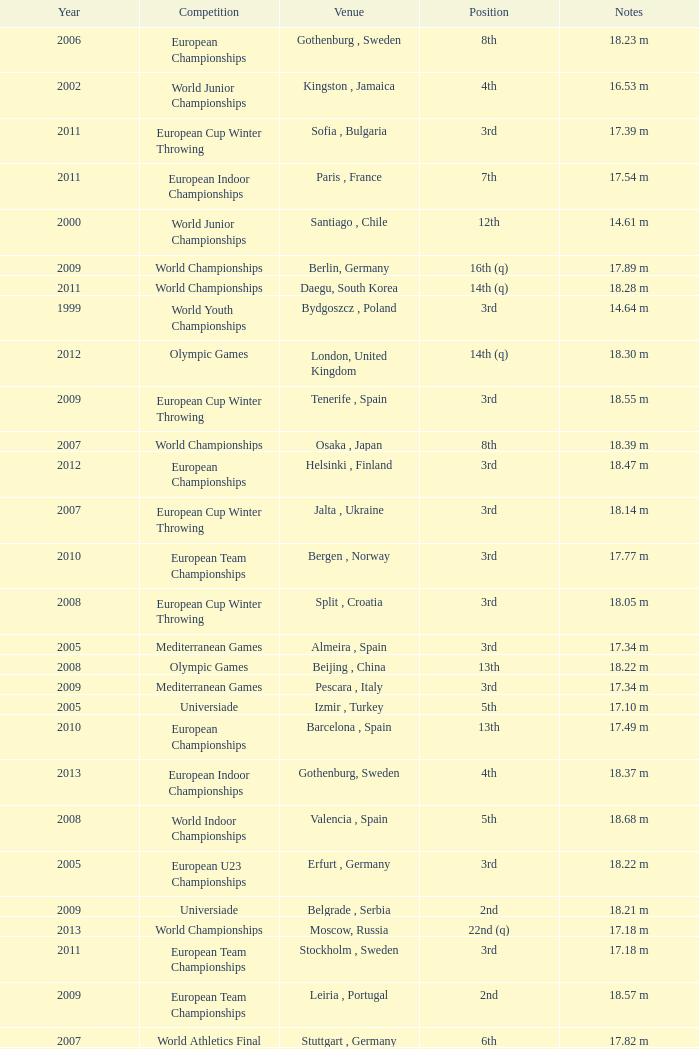Where were the Mediterranean games after 2005? Pescara , Italy. 